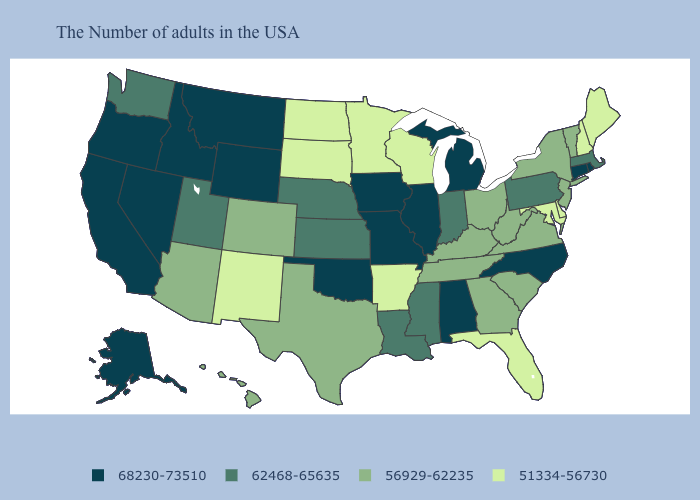Does West Virginia have the highest value in the USA?
Answer briefly. No. Among the states that border Texas , which have the lowest value?
Keep it brief. Arkansas, New Mexico. Which states hav the highest value in the South?
Short answer required. North Carolina, Alabama, Oklahoma. What is the value of New Jersey?
Be succinct. 56929-62235. What is the lowest value in states that border Oklahoma?
Answer briefly. 51334-56730. Name the states that have a value in the range 68230-73510?
Give a very brief answer. Rhode Island, Connecticut, North Carolina, Michigan, Alabama, Illinois, Missouri, Iowa, Oklahoma, Wyoming, Montana, Idaho, Nevada, California, Oregon, Alaska. Does Colorado have the lowest value in the West?
Short answer required. No. Does the first symbol in the legend represent the smallest category?
Concise answer only. No. What is the value of Connecticut?
Concise answer only. 68230-73510. Name the states that have a value in the range 51334-56730?
Write a very short answer. Maine, New Hampshire, Delaware, Maryland, Florida, Wisconsin, Arkansas, Minnesota, South Dakota, North Dakota, New Mexico. Does Florida have the lowest value in the USA?
Write a very short answer. Yes. Does the first symbol in the legend represent the smallest category?
Answer briefly. No. What is the lowest value in states that border Massachusetts?
Quick response, please. 51334-56730. 